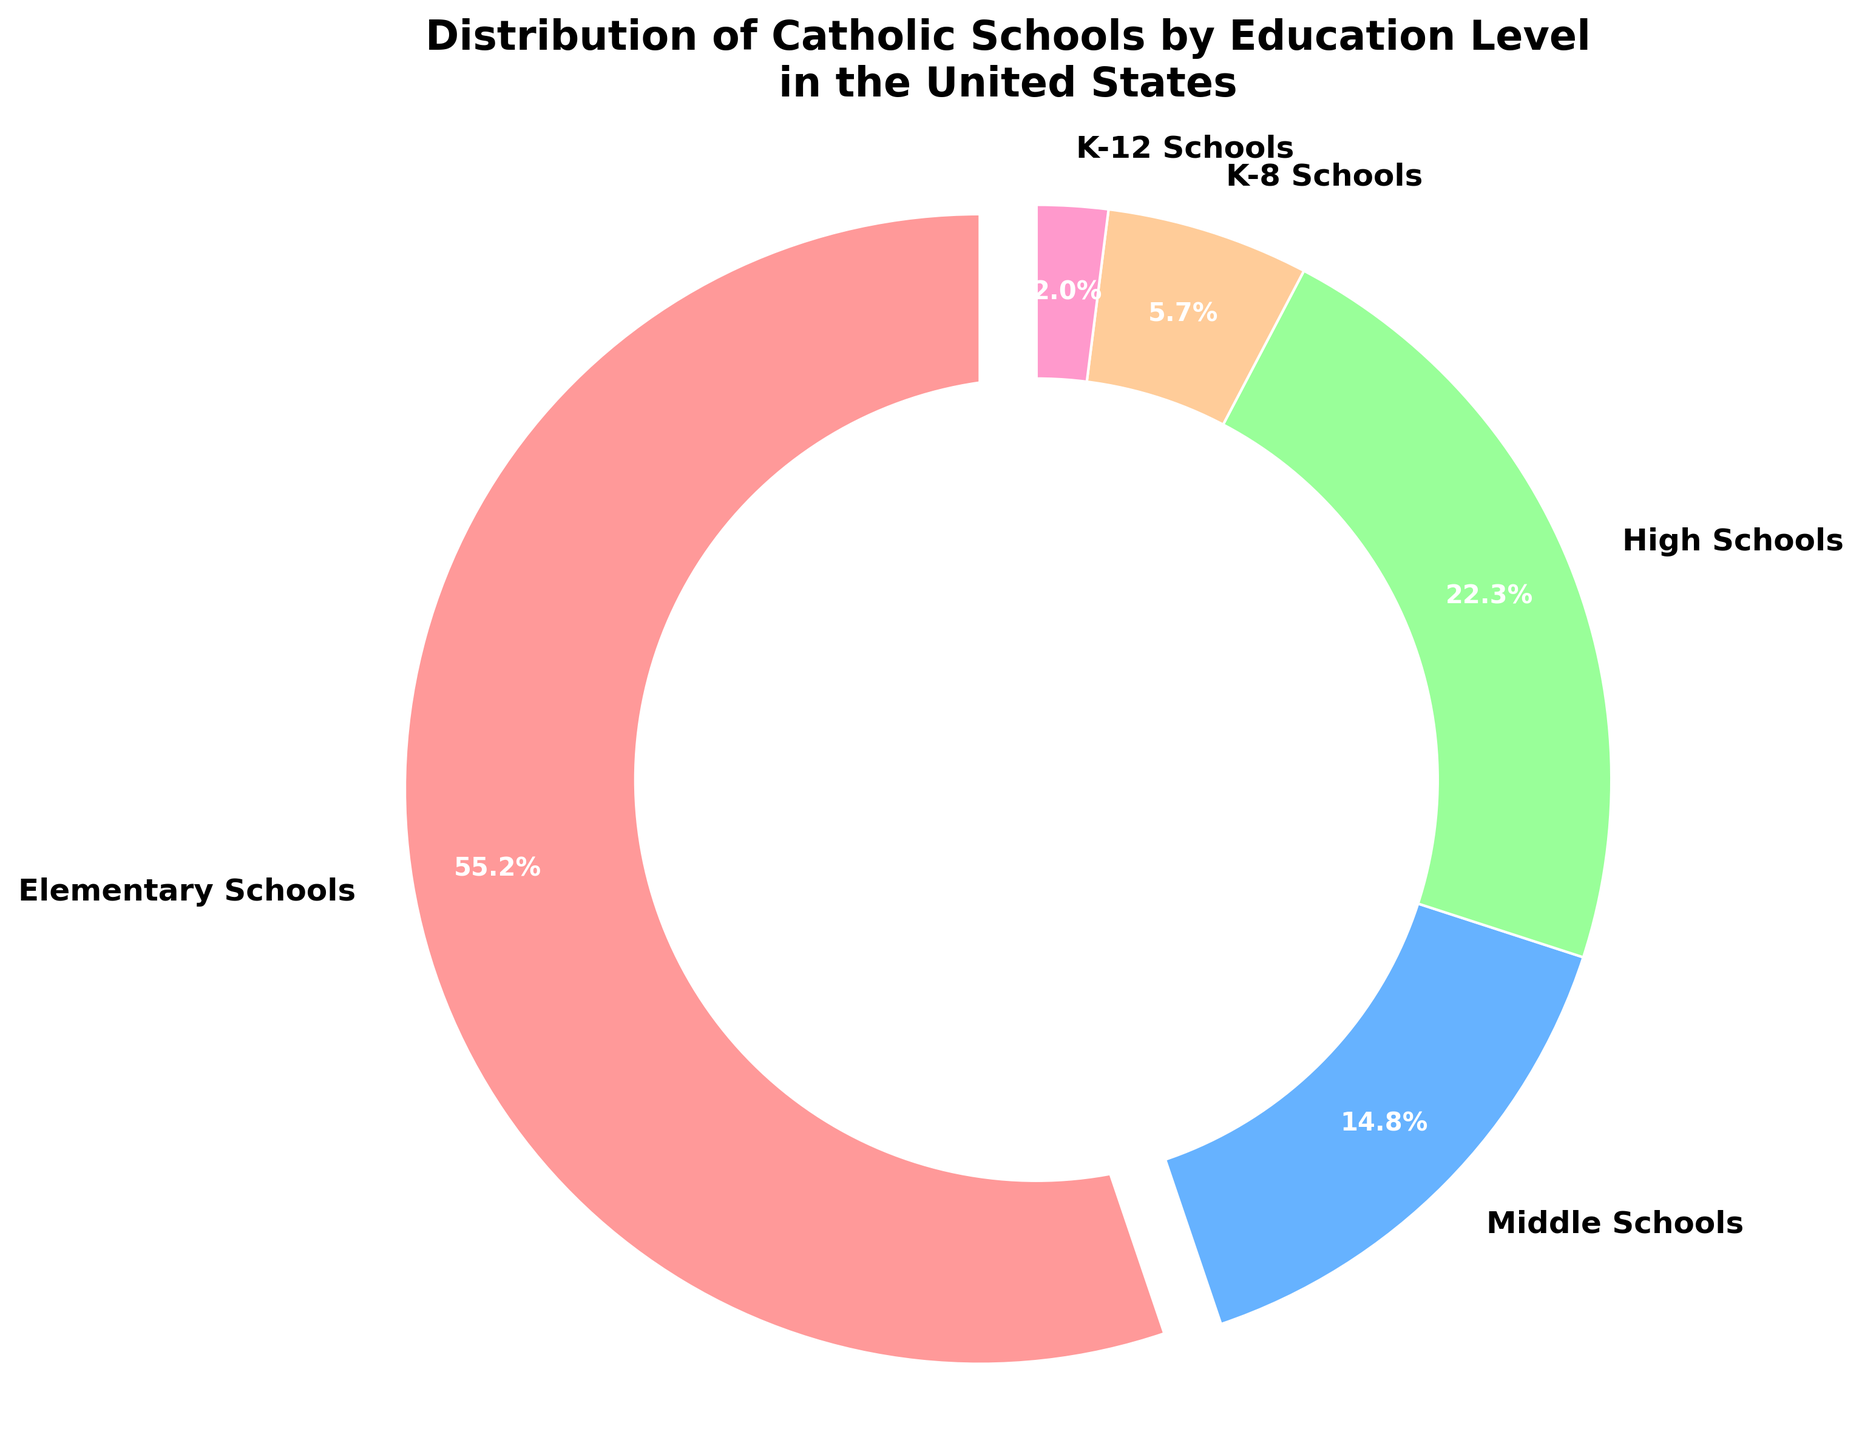What percentage of Catholic schools in the United States are elementary or high schools combined? To find the combined percentage of elementary and high schools, add the two percentages: 55.2% (elementary) + 22.3% (high schools). Hence, the combined percentage is 55.2 + 22.3 = 77.5%.
Answer: 77.5% Which level has a higher percentage: middle schools or K-8 schools? By comparing the percentages, we see that middle schools have 14.8%, and K-8 schools have 5.7%. Since 14.8% is greater than 5.7%, middle schools have a higher percentage.
Answer: Middle schools What is the difference between the percentage of elementary schools and high schools? Subtract the percentage of high schools from elementary schools: 55.2% - 22.3%. Thus, the difference is 55.2 - 22.3 = 32.9%.
Answer: 32.9% What percentage of Catholic schools in the United States cover grades K-8 or K-12? Add the percentages of K-8 schools and K-12 schools: 5.7% (K-8) + 2.0% (K-12). So, the combined percentage is 5.7 + 2.0 = 7.7%.
Answer: 7.7% What is the smallest category of Catholic schools by education level in the United States? By looking at the percentages, K-12 schools have the smallest percentage at 2.0%.
Answer: K-12 schools If you combine the percentages of middle and high schools, does it exceed the percentage of elementary schools? Add the percentages of middle and high schools: 14.8% + 22.3% = 37.1%. Since 37.1% is less than 55.2%, the combined percentage does not exceed that of elementary schools.
Answer: No Which section of the pie chart is colored in light blue? The second section representing middle schools is light blue. This can be inferred from the order of the data and the specified colors.
Answer: Middle schools What percentage of Catholic schools are neither elementary nor high schools? Subtract the combined percentage of elementary and high schools from 100%: 100% - (55.2% + 22.3%) = 100% - 77.5% = 22.5%. This percentage includes middle, K-8, and K-12 schools.
Answer: 22.5% What is the relationship between the percentage of K-8 schools and the combined percentage of K-12 and high schools? First, find the combined percentage of K-12 and high schools: 2.0% (K-12) + 22.3% (high schools) = 24.3%. Then compare it with K-8 schools at 5.7%. Since 24.3% is greater than 5.7%, the combined percentage of K-12 and high schools is larger.
Answer: Combined K-12 and high schools is larger How many percentage points more than K-12 schools are elementary schools? Subtract the percentage of K-12 schools from elementary schools: 55.2% - 2.0%. Hence, the difference is 55.2 - 2.0 = 53.2 percentage points.
Answer: 53.2 percentage points 